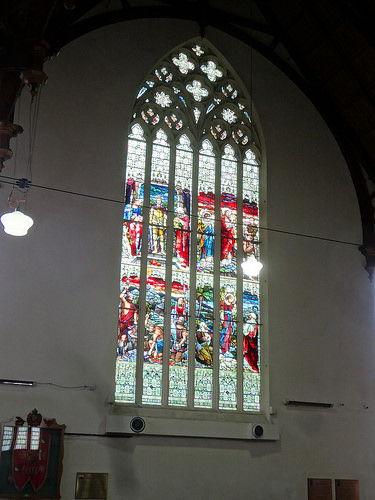<image>
Is there a wall in front of the window? No. The wall is not in front of the window. The spatial positioning shows a different relationship between these objects. 